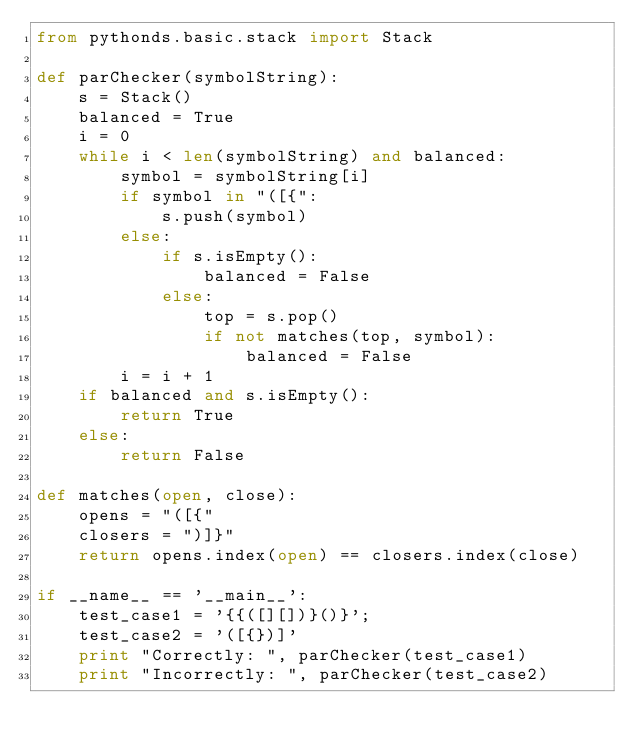<code> <loc_0><loc_0><loc_500><loc_500><_Python_>from pythonds.basic.stack import Stack

def parChecker(symbolString):
    s = Stack()
    balanced = True
    i = 0
    while i < len(symbolString) and balanced:
        symbol = symbolString[i]
        if symbol in "([{":
            s.push(symbol)
        else:
            if s.isEmpty():
                balanced = False
            else:
                top = s.pop()
                if not matches(top, symbol):
                    balanced = False
        i = i + 1
    if balanced and s.isEmpty():
        return True
    else:
        return False

def matches(open, close):
    opens = "([{"
    closers = ")]}"
    return opens.index(open) == closers.index(close)

if __name__ == '__main__':
    test_case1 = '{{([][])}()}';
    test_case2 = '([{})]'
    print "Correctly: ", parChecker(test_case1)
    print "Incorrectly: ", parChecker(test_case2)
</code> 